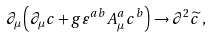<formula> <loc_0><loc_0><loc_500><loc_500>\partial _ { \mu } \left ( \partial _ { \mu } c + g \varepsilon ^ { a b } A _ { \mu } ^ { a } c ^ { b } \right ) \rightarrow \partial ^ { 2 } \widetilde { c } \, ,</formula> 